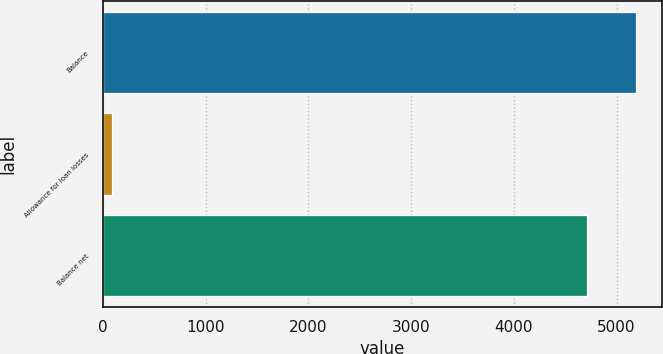<chart> <loc_0><loc_0><loc_500><loc_500><bar_chart><fcel>Balance<fcel>Allowance for loan losses<fcel>Balance net<nl><fcel>5186.5<fcel>89<fcel>4715<nl></chart> 